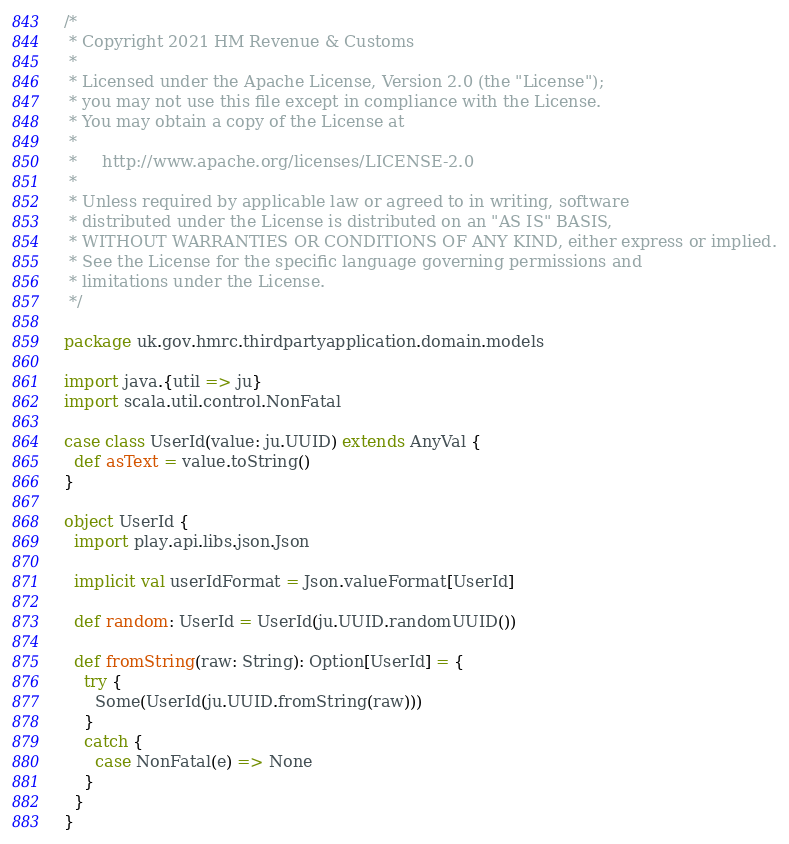Convert code to text. <code><loc_0><loc_0><loc_500><loc_500><_Scala_>/*
 * Copyright 2021 HM Revenue & Customs
 *
 * Licensed under the Apache License, Version 2.0 (the "License");
 * you may not use this file except in compliance with the License.
 * You may obtain a copy of the License at
 *
 *     http://www.apache.org/licenses/LICENSE-2.0
 *
 * Unless required by applicable law or agreed to in writing, software
 * distributed under the License is distributed on an "AS IS" BASIS,
 * WITHOUT WARRANTIES OR CONDITIONS OF ANY KIND, either express or implied.
 * See the License for the specific language governing permissions and
 * limitations under the License.
 */

package uk.gov.hmrc.thirdpartyapplication.domain.models

import java.{util => ju}
import scala.util.control.NonFatal

case class UserId(value: ju.UUID) extends AnyVal {
  def asText = value.toString()
}

object UserId {
  import play.api.libs.json.Json
  
  implicit val userIdFormat = Json.valueFormat[UserId]

  def random: UserId = UserId(ju.UUID.randomUUID())

  def fromString(raw: String): Option[UserId] = {
    try {
      Some(UserId(ju.UUID.fromString(raw)))
    }
    catch {
      case NonFatal(e) => None
    }
  }
}
</code> 